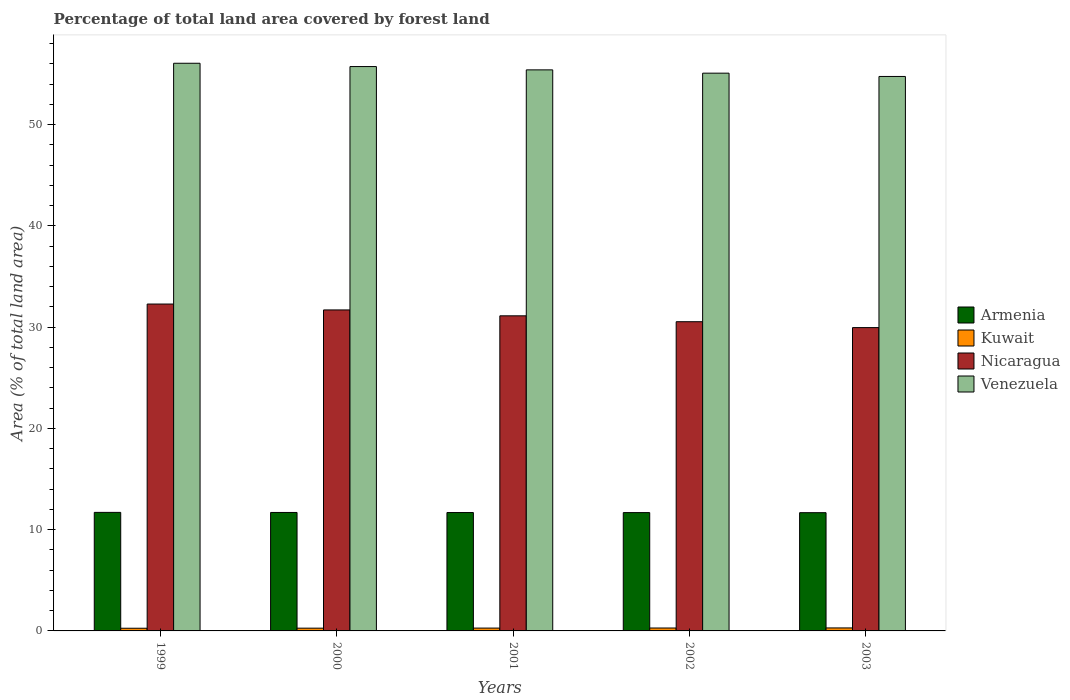How many different coloured bars are there?
Offer a terse response. 4. Are the number of bars per tick equal to the number of legend labels?
Your response must be concise. Yes. Are the number of bars on each tick of the X-axis equal?
Provide a succinct answer. Yes. How many bars are there on the 1st tick from the left?
Provide a succinct answer. 4. What is the label of the 3rd group of bars from the left?
Offer a very short reply. 2001. In how many cases, is the number of bars for a given year not equal to the number of legend labels?
Provide a short and direct response. 0. What is the percentage of forest land in Venezuela in 1999?
Offer a terse response. 56.05. Across all years, what is the maximum percentage of forest land in Kuwait?
Your response must be concise. 0.3. Across all years, what is the minimum percentage of forest land in Kuwait?
Provide a succinct answer. 0.26. What is the total percentage of forest land in Venezuela in the graph?
Provide a succinct answer. 276.99. What is the difference between the percentage of forest land in Armenia in 1999 and that in 2002?
Offer a very short reply. 0.02. What is the difference between the percentage of forest land in Nicaragua in 2000 and the percentage of forest land in Kuwait in 1999?
Keep it short and to the point. 31.43. What is the average percentage of forest land in Nicaragua per year?
Your response must be concise. 31.11. In the year 1999, what is the difference between the percentage of forest land in Venezuela and percentage of forest land in Armenia?
Offer a terse response. 44.35. In how many years, is the percentage of forest land in Venezuela greater than 14 %?
Make the answer very short. 5. What is the ratio of the percentage of forest land in Venezuela in 1999 to that in 2002?
Ensure brevity in your answer.  1.02. What is the difference between the highest and the second highest percentage of forest land in Kuwait?
Your answer should be compact. 0.01. What is the difference between the highest and the lowest percentage of forest land in Armenia?
Give a very brief answer. 0.03. Is the sum of the percentage of forest land in Kuwait in 1999 and 2001 greater than the maximum percentage of forest land in Armenia across all years?
Give a very brief answer. No. Is it the case that in every year, the sum of the percentage of forest land in Nicaragua and percentage of forest land in Kuwait is greater than the sum of percentage of forest land in Armenia and percentage of forest land in Venezuela?
Give a very brief answer. Yes. What does the 1st bar from the left in 1999 represents?
Provide a succinct answer. Armenia. What does the 4th bar from the right in 2002 represents?
Give a very brief answer. Armenia. How many bars are there?
Your response must be concise. 20. Are all the bars in the graph horizontal?
Provide a short and direct response. No. How many years are there in the graph?
Provide a short and direct response. 5. Are the values on the major ticks of Y-axis written in scientific E-notation?
Your response must be concise. No. Does the graph contain grids?
Your answer should be compact. No. How many legend labels are there?
Provide a succinct answer. 4. What is the title of the graph?
Your response must be concise. Percentage of total land area covered by forest land. Does "Mauritius" appear as one of the legend labels in the graph?
Provide a succinct answer. No. What is the label or title of the X-axis?
Your response must be concise. Years. What is the label or title of the Y-axis?
Make the answer very short. Area (% of total land area). What is the Area (% of total land area) of Armenia in 1999?
Offer a very short reply. 11.7. What is the Area (% of total land area) in Kuwait in 1999?
Provide a succinct answer. 0.26. What is the Area (% of total land area) in Nicaragua in 1999?
Make the answer very short. 32.28. What is the Area (% of total land area) in Venezuela in 1999?
Your response must be concise. 56.05. What is the Area (% of total land area) of Armenia in 2000?
Your answer should be very brief. 11.7. What is the Area (% of total land area) in Kuwait in 2000?
Keep it short and to the point. 0.27. What is the Area (% of total land area) of Nicaragua in 2000?
Offer a very short reply. 31.69. What is the Area (% of total land area) of Venezuela in 2000?
Give a very brief answer. 55.72. What is the Area (% of total land area) of Armenia in 2001?
Offer a very short reply. 11.69. What is the Area (% of total land area) of Kuwait in 2001?
Give a very brief answer. 0.28. What is the Area (% of total land area) in Nicaragua in 2001?
Your response must be concise. 31.11. What is the Area (% of total land area) of Venezuela in 2001?
Your response must be concise. 55.4. What is the Area (% of total land area) of Armenia in 2002?
Keep it short and to the point. 11.68. What is the Area (% of total land area) in Kuwait in 2002?
Ensure brevity in your answer.  0.29. What is the Area (% of total land area) of Nicaragua in 2002?
Make the answer very short. 30.53. What is the Area (% of total land area) of Venezuela in 2002?
Offer a very short reply. 55.07. What is the Area (% of total land area) of Armenia in 2003?
Ensure brevity in your answer.  11.68. What is the Area (% of total land area) of Kuwait in 2003?
Offer a terse response. 0.3. What is the Area (% of total land area) of Nicaragua in 2003?
Give a very brief answer. 29.95. What is the Area (% of total land area) of Venezuela in 2003?
Offer a very short reply. 54.75. Across all years, what is the maximum Area (% of total land area) in Armenia?
Your response must be concise. 11.7. Across all years, what is the maximum Area (% of total land area) in Kuwait?
Make the answer very short. 0.3. Across all years, what is the maximum Area (% of total land area) of Nicaragua?
Make the answer very short. 32.28. Across all years, what is the maximum Area (% of total land area) in Venezuela?
Your answer should be compact. 56.05. Across all years, what is the minimum Area (% of total land area) of Armenia?
Give a very brief answer. 11.68. Across all years, what is the minimum Area (% of total land area) of Kuwait?
Your answer should be compact. 0.26. Across all years, what is the minimum Area (% of total land area) of Nicaragua?
Offer a very short reply. 29.95. Across all years, what is the minimum Area (% of total land area) of Venezuela?
Provide a short and direct response. 54.75. What is the total Area (% of total land area) in Armenia in the graph?
Your answer should be very brief. 58.45. What is the total Area (% of total land area) in Kuwait in the graph?
Make the answer very short. 1.4. What is the total Area (% of total land area) of Nicaragua in the graph?
Offer a terse response. 155.56. What is the total Area (% of total land area) in Venezuela in the graph?
Make the answer very short. 276.99. What is the difference between the Area (% of total land area) of Armenia in 1999 and that in 2000?
Keep it short and to the point. 0.01. What is the difference between the Area (% of total land area) of Kuwait in 1999 and that in 2000?
Ensure brevity in your answer.  -0.01. What is the difference between the Area (% of total land area) of Nicaragua in 1999 and that in 2000?
Provide a succinct answer. 0.58. What is the difference between the Area (% of total land area) in Venezuela in 1999 and that in 2000?
Offer a terse response. 0.33. What is the difference between the Area (% of total land area) in Armenia in 1999 and that in 2001?
Your answer should be compact. 0.01. What is the difference between the Area (% of total land area) in Kuwait in 1999 and that in 2001?
Your answer should be very brief. -0.02. What is the difference between the Area (% of total land area) in Nicaragua in 1999 and that in 2001?
Your answer should be compact. 1.16. What is the difference between the Area (% of total land area) of Venezuela in 1999 and that in 2001?
Give a very brief answer. 0.65. What is the difference between the Area (% of total land area) in Armenia in 1999 and that in 2002?
Offer a very short reply. 0.02. What is the difference between the Area (% of total land area) of Kuwait in 1999 and that in 2002?
Give a very brief answer. -0.02. What is the difference between the Area (% of total land area) in Nicaragua in 1999 and that in 2002?
Give a very brief answer. 1.75. What is the difference between the Area (% of total land area) of Venezuela in 1999 and that in 2002?
Offer a terse response. 0.98. What is the difference between the Area (% of total land area) of Armenia in 1999 and that in 2003?
Your answer should be very brief. 0.03. What is the difference between the Area (% of total land area) of Kuwait in 1999 and that in 2003?
Provide a succinct answer. -0.03. What is the difference between the Area (% of total land area) of Nicaragua in 1999 and that in 2003?
Offer a very short reply. 2.33. What is the difference between the Area (% of total land area) in Venezuela in 1999 and that in 2003?
Make the answer very short. 1.3. What is the difference between the Area (% of total land area) of Armenia in 2000 and that in 2001?
Provide a succinct answer. 0.01. What is the difference between the Area (% of total land area) in Kuwait in 2000 and that in 2001?
Ensure brevity in your answer.  -0.01. What is the difference between the Area (% of total land area) in Nicaragua in 2000 and that in 2001?
Give a very brief answer. 0.58. What is the difference between the Area (% of total land area) of Venezuela in 2000 and that in 2001?
Your answer should be very brief. 0.33. What is the difference between the Area (% of total land area) of Armenia in 2000 and that in 2002?
Your answer should be very brief. 0.01. What is the difference between the Area (% of total land area) of Kuwait in 2000 and that in 2002?
Provide a succinct answer. -0.02. What is the difference between the Area (% of total land area) of Nicaragua in 2000 and that in 2002?
Provide a succinct answer. 1.16. What is the difference between the Area (% of total land area) in Venezuela in 2000 and that in 2002?
Keep it short and to the point. 0.65. What is the difference between the Area (% of total land area) in Armenia in 2000 and that in 2003?
Make the answer very short. 0.02. What is the difference between the Area (% of total land area) in Kuwait in 2000 and that in 2003?
Give a very brief answer. -0.02. What is the difference between the Area (% of total land area) in Nicaragua in 2000 and that in 2003?
Provide a short and direct response. 1.75. What is the difference between the Area (% of total land area) in Venezuela in 2000 and that in 2003?
Your answer should be very brief. 0.98. What is the difference between the Area (% of total land area) in Armenia in 2001 and that in 2002?
Offer a terse response. 0.01. What is the difference between the Area (% of total land area) in Kuwait in 2001 and that in 2002?
Provide a short and direct response. -0.01. What is the difference between the Area (% of total land area) of Nicaragua in 2001 and that in 2002?
Your answer should be compact. 0.58. What is the difference between the Area (% of total land area) in Venezuela in 2001 and that in 2002?
Provide a short and direct response. 0.33. What is the difference between the Area (% of total land area) in Armenia in 2001 and that in 2003?
Provide a short and direct response. 0.01. What is the difference between the Area (% of total land area) in Kuwait in 2001 and that in 2003?
Ensure brevity in your answer.  -0.02. What is the difference between the Area (% of total land area) in Nicaragua in 2001 and that in 2003?
Your answer should be compact. 1.16. What is the difference between the Area (% of total land area) in Venezuela in 2001 and that in 2003?
Make the answer very short. 0.65. What is the difference between the Area (% of total land area) in Armenia in 2002 and that in 2003?
Provide a short and direct response. 0.01. What is the difference between the Area (% of total land area) in Kuwait in 2002 and that in 2003?
Provide a succinct answer. -0.01. What is the difference between the Area (% of total land area) in Nicaragua in 2002 and that in 2003?
Keep it short and to the point. 0.58. What is the difference between the Area (% of total land area) in Venezuela in 2002 and that in 2003?
Keep it short and to the point. 0.33. What is the difference between the Area (% of total land area) in Armenia in 1999 and the Area (% of total land area) in Kuwait in 2000?
Ensure brevity in your answer.  11.43. What is the difference between the Area (% of total land area) of Armenia in 1999 and the Area (% of total land area) of Nicaragua in 2000?
Your response must be concise. -19.99. What is the difference between the Area (% of total land area) of Armenia in 1999 and the Area (% of total land area) of Venezuela in 2000?
Your answer should be compact. -44.02. What is the difference between the Area (% of total land area) in Kuwait in 1999 and the Area (% of total land area) in Nicaragua in 2000?
Your answer should be very brief. -31.43. What is the difference between the Area (% of total land area) in Kuwait in 1999 and the Area (% of total land area) in Venezuela in 2000?
Offer a terse response. -55.46. What is the difference between the Area (% of total land area) of Nicaragua in 1999 and the Area (% of total land area) of Venezuela in 2000?
Offer a very short reply. -23.45. What is the difference between the Area (% of total land area) in Armenia in 1999 and the Area (% of total land area) in Kuwait in 2001?
Give a very brief answer. 11.42. What is the difference between the Area (% of total land area) of Armenia in 1999 and the Area (% of total land area) of Nicaragua in 2001?
Your answer should be very brief. -19.41. What is the difference between the Area (% of total land area) in Armenia in 1999 and the Area (% of total land area) in Venezuela in 2001?
Ensure brevity in your answer.  -43.69. What is the difference between the Area (% of total land area) in Kuwait in 1999 and the Area (% of total land area) in Nicaragua in 2001?
Provide a short and direct response. -30.85. What is the difference between the Area (% of total land area) of Kuwait in 1999 and the Area (% of total land area) of Venezuela in 2001?
Your answer should be very brief. -55.13. What is the difference between the Area (% of total land area) of Nicaragua in 1999 and the Area (% of total land area) of Venezuela in 2001?
Offer a very short reply. -23.12. What is the difference between the Area (% of total land area) of Armenia in 1999 and the Area (% of total land area) of Kuwait in 2002?
Your response must be concise. 11.42. What is the difference between the Area (% of total land area) in Armenia in 1999 and the Area (% of total land area) in Nicaragua in 2002?
Provide a succinct answer. -18.83. What is the difference between the Area (% of total land area) in Armenia in 1999 and the Area (% of total land area) in Venezuela in 2002?
Provide a succinct answer. -43.37. What is the difference between the Area (% of total land area) of Kuwait in 1999 and the Area (% of total land area) of Nicaragua in 2002?
Provide a succinct answer. -30.27. What is the difference between the Area (% of total land area) of Kuwait in 1999 and the Area (% of total land area) of Venezuela in 2002?
Make the answer very short. -54.81. What is the difference between the Area (% of total land area) in Nicaragua in 1999 and the Area (% of total land area) in Venezuela in 2002?
Your answer should be very brief. -22.8. What is the difference between the Area (% of total land area) in Armenia in 1999 and the Area (% of total land area) in Kuwait in 2003?
Provide a short and direct response. 11.41. What is the difference between the Area (% of total land area) in Armenia in 1999 and the Area (% of total land area) in Nicaragua in 2003?
Ensure brevity in your answer.  -18.24. What is the difference between the Area (% of total land area) of Armenia in 1999 and the Area (% of total land area) of Venezuela in 2003?
Your response must be concise. -43.04. What is the difference between the Area (% of total land area) of Kuwait in 1999 and the Area (% of total land area) of Nicaragua in 2003?
Your response must be concise. -29.68. What is the difference between the Area (% of total land area) of Kuwait in 1999 and the Area (% of total land area) of Venezuela in 2003?
Make the answer very short. -54.48. What is the difference between the Area (% of total land area) in Nicaragua in 1999 and the Area (% of total land area) in Venezuela in 2003?
Your response must be concise. -22.47. What is the difference between the Area (% of total land area) in Armenia in 2000 and the Area (% of total land area) in Kuwait in 2001?
Provide a succinct answer. 11.42. What is the difference between the Area (% of total land area) of Armenia in 2000 and the Area (% of total land area) of Nicaragua in 2001?
Offer a terse response. -19.42. What is the difference between the Area (% of total land area) in Armenia in 2000 and the Area (% of total land area) in Venezuela in 2001?
Keep it short and to the point. -43.7. What is the difference between the Area (% of total land area) of Kuwait in 2000 and the Area (% of total land area) of Nicaragua in 2001?
Your answer should be compact. -30.84. What is the difference between the Area (% of total land area) of Kuwait in 2000 and the Area (% of total land area) of Venezuela in 2001?
Keep it short and to the point. -55.13. What is the difference between the Area (% of total land area) in Nicaragua in 2000 and the Area (% of total land area) in Venezuela in 2001?
Make the answer very short. -23.7. What is the difference between the Area (% of total land area) in Armenia in 2000 and the Area (% of total land area) in Kuwait in 2002?
Your response must be concise. 11.41. What is the difference between the Area (% of total land area) in Armenia in 2000 and the Area (% of total land area) in Nicaragua in 2002?
Provide a succinct answer. -18.83. What is the difference between the Area (% of total land area) of Armenia in 2000 and the Area (% of total land area) of Venezuela in 2002?
Keep it short and to the point. -43.38. What is the difference between the Area (% of total land area) of Kuwait in 2000 and the Area (% of total land area) of Nicaragua in 2002?
Offer a terse response. -30.26. What is the difference between the Area (% of total land area) in Kuwait in 2000 and the Area (% of total land area) in Venezuela in 2002?
Ensure brevity in your answer.  -54.8. What is the difference between the Area (% of total land area) of Nicaragua in 2000 and the Area (% of total land area) of Venezuela in 2002?
Offer a very short reply. -23.38. What is the difference between the Area (% of total land area) of Armenia in 2000 and the Area (% of total land area) of Kuwait in 2003?
Your response must be concise. 11.4. What is the difference between the Area (% of total land area) in Armenia in 2000 and the Area (% of total land area) in Nicaragua in 2003?
Offer a terse response. -18.25. What is the difference between the Area (% of total land area) in Armenia in 2000 and the Area (% of total land area) in Venezuela in 2003?
Ensure brevity in your answer.  -43.05. What is the difference between the Area (% of total land area) of Kuwait in 2000 and the Area (% of total land area) of Nicaragua in 2003?
Offer a terse response. -29.68. What is the difference between the Area (% of total land area) in Kuwait in 2000 and the Area (% of total land area) in Venezuela in 2003?
Your answer should be very brief. -54.47. What is the difference between the Area (% of total land area) of Nicaragua in 2000 and the Area (% of total land area) of Venezuela in 2003?
Offer a very short reply. -23.05. What is the difference between the Area (% of total land area) in Armenia in 2001 and the Area (% of total land area) in Kuwait in 2002?
Your response must be concise. 11.4. What is the difference between the Area (% of total land area) in Armenia in 2001 and the Area (% of total land area) in Nicaragua in 2002?
Keep it short and to the point. -18.84. What is the difference between the Area (% of total land area) of Armenia in 2001 and the Area (% of total land area) of Venezuela in 2002?
Your answer should be very brief. -43.38. What is the difference between the Area (% of total land area) of Kuwait in 2001 and the Area (% of total land area) of Nicaragua in 2002?
Ensure brevity in your answer.  -30.25. What is the difference between the Area (% of total land area) of Kuwait in 2001 and the Area (% of total land area) of Venezuela in 2002?
Keep it short and to the point. -54.79. What is the difference between the Area (% of total land area) in Nicaragua in 2001 and the Area (% of total land area) in Venezuela in 2002?
Offer a very short reply. -23.96. What is the difference between the Area (% of total land area) of Armenia in 2001 and the Area (% of total land area) of Kuwait in 2003?
Offer a terse response. 11.39. What is the difference between the Area (% of total land area) in Armenia in 2001 and the Area (% of total land area) in Nicaragua in 2003?
Your answer should be very brief. -18.26. What is the difference between the Area (% of total land area) in Armenia in 2001 and the Area (% of total land area) in Venezuela in 2003?
Offer a terse response. -43.06. What is the difference between the Area (% of total land area) of Kuwait in 2001 and the Area (% of total land area) of Nicaragua in 2003?
Ensure brevity in your answer.  -29.67. What is the difference between the Area (% of total land area) of Kuwait in 2001 and the Area (% of total land area) of Venezuela in 2003?
Give a very brief answer. -54.47. What is the difference between the Area (% of total land area) in Nicaragua in 2001 and the Area (% of total land area) in Venezuela in 2003?
Provide a succinct answer. -23.63. What is the difference between the Area (% of total land area) of Armenia in 2002 and the Area (% of total land area) of Kuwait in 2003?
Your answer should be very brief. 11.39. What is the difference between the Area (% of total land area) of Armenia in 2002 and the Area (% of total land area) of Nicaragua in 2003?
Ensure brevity in your answer.  -18.27. What is the difference between the Area (% of total land area) of Armenia in 2002 and the Area (% of total land area) of Venezuela in 2003?
Provide a succinct answer. -43.06. What is the difference between the Area (% of total land area) in Kuwait in 2002 and the Area (% of total land area) in Nicaragua in 2003?
Your answer should be very brief. -29.66. What is the difference between the Area (% of total land area) in Kuwait in 2002 and the Area (% of total land area) in Venezuela in 2003?
Offer a very short reply. -54.46. What is the difference between the Area (% of total land area) in Nicaragua in 2002 and the Area (% of total land area) in Venezuela in 2003?
Make the answer very short. -24.22. What is the average Area (% of total land area) of Armenia per year?
Ensure brevity in your answer.  11.69. What is the average Area (% of total land area) in Kuwait per year?
Offer a terse response. 0.28. What is the average Area (% of total land area) of Nicaragua per year?
Your response must be concise. 31.11. What is the average Area (% of total land area) of Venezuela per year?
Provide a short and direct response. 55.4. In the year 1999, what is the difference between the Area (% of total land area) of Armenia and Area (% of total land area) of Kuwait?
Provide a succinct answer. 11.44. In the year 1999, what is the difference between the Area (% of total land area) in Armenia and Area (% of total land area) in Nicaragua?
Give a very brief answer. -20.57. In the year 1999, what is the difference between the Area (% of total land area) in Armenia and Area (% of total land area) in Venezuela?
Your response must be concise. -44.35. In the year 1999, what is the difference between the Area (% of total land area) in Kuwait and Area (% of total land area) in Nicaragua?
Your answer should be compact. -32.01. In the year 1999, what is the difference between the Area (% of total land area) of Kuwait and Area (% of total land area) of Venezuela?
Ensure brevity in your answer.  -55.79. In the year 1999, what is the difference between the Area (% of total land area) in Nicaragua and Area (% of total land area) in Venezuela?
Your response must be concise. -23.77. In the year 2000, what is the difference between the Area (% of total land area) of Armenia and Area (% of total land area) of Kuwait?
Keep it short and to the point. 11.42. In the year 2000, what is the difference between the Area (% of total land area) of Armenia and Area (% of total land area) of Nicaragua?
Provide a succinct answer. -20. In the year 2000, what is the difference between the Area (% of total land area) in Armenia and Area (% of total land area) in Venezuela?
Give a very brief answer. -44.03. In the year 2000, what is the difference between the Area (% of total land area) of Kuwait and Area (% of total land area) of Nicaragua?
Offer a very short reply. -31.42. In the year 2000, what is the difference between the Area (% of total land area) of Kuwait and Area (% of total land area) of Venezuela?
Give a very brief answer. -55.45. In the year 2000, what is the difference between the Area (% of total land area) in Nicaragua and Area (% of total land area) in Venezuela?
Your answer should be compact. -24.03. In the year 2001, what is the difference between the Area (% of total land area) in Armenia and Area (% of total land area) in Kuwait?
Give a very brief answer. 11.41. In the year 2001, what is the difference between the Area (% of total land area) in Armenia and Area (% of total land area) in Nicaragua?
Give a very brief answer. -19.42. In the year 2001, what is the difference between the Area (% of total land area) of Armenia and Area (% of total land area) of Venezuela?
Make the answer very short. -43.71. In the year 2001, what is the difference between the Area (% of total land area) of Kuwait and Area (% of total land area) of Nicaragua?
Your response must be concise. -30.83. In the year 2001, what is the difference between the Area (% of total land area) in Kuwait and Area (% of total land area) in Venezuela?
Keep it short and to the point. -55.12. In the year 2001, what is the difference between the Area (% of total land area) in Nicaragua and Area (% of total land area) in Venezuela?
Offer a terse response. -24.29. In the year 2002, what is the difference between the Area (% of total land area) of Armenia and Area (% of total land area) of Kuwait?
Your answer should be compact. 11.39. In the year 2002, what is the difference between the Area (% of total land area) in Armenia and Area (% of total land area) in Nicaragua?
Give a very brief answer. -18.85. In the year 2002, what is the difference between the Area (% of total land area) in Armenia and Area (% of total land area) in Venezuela?
Offer a terse response. -43.39. In the year 2002, what is the difference between the Area (% of total land area) of Kuwait and Area (% of total land area) of Nicaragua?
Provide a short and direct response. -30.24. In the year 2002, what is the difference between the Area (% of total land area) in Kuwait and Area (% of total land area) in Venezuela?
Your response must be concise. -54.78. In the year 2002, what is the difference between the Area (% of total land area) in Nicaragua and Area (% of total land area) in Venezuela?
Offer a very short reply. -24.54. In the year 2003, what is the difference between the Area (% of total land area) in Armenia and Area (% of total land area) in Kuwait?
Your response must be concise. 11.38. In the year 2003, what is the difference between the Area (% of total land area) in Armenia and Area (% of total land area) in Nicaragua?
Your answer should be very brief. -18.27. In the year 2003, what is the difference between the Area (% of total land area) in Armenia and Area (% of total land area) in Venezuela?
Keep it short and to the point. -43.07. In the year 2003, what is the difference between the Area (% of total land area) in Kuwait and Area (% of total land area) in Nicaragua?
Make the answer very short. -29.65. In the year 2003, what is the difference between the Area (% of total land area) in Kuwait and Area (% of total land area) in Venezuela?
Offer a terse response. -54.45. In the year 2003, what is the difference between the Area (% of total land area) of Nicaragua and Area (% of total land area) of Venezuela?
Provide a succinct answer. -24.8. What is the ratio of the Area (% of total land area) of Armenia in 1999 to that in 2000?
Your response must be concise. 1. What is the ratio of the Area (% of total land area) in Kuwait in 1999 to that in 2000?
Your answer should be compact. 0.97. What is the ratio of the Area (% of total land area) of Nicaragua in 1999 to that in 2000?
Give a very brief answer. 1.02. What is the ratio of the Area (% of total land area) in Armenia in 1999 to that in 2001?
Give a very brief answer. 1. What is the ratio of the Area (% of total land area) in Kuwait in 1999 to that in 2001?
Provide a succinct answer. 0.94. What is the ratio of the Area (% of total land area) in Nicaragua in 1999 to that in 2001?
Ensure brevity in your answer.  1.04. What is the ratio of the Area (% of total land area) of Venezuela in 1999 to that in 2001?
Keep it short and to the point. 1.01. What is the ratio of the Area (% of total land area) of Armenia in 1999 to that in 2002?
Your answer should be very brief. 1. What is the ratio of the Area (% of total land area) in Kuwait in 1999 to that in 2002?
Your answer should be compact. 0.92. What is the ratio of the Area (% of total land area) of Nicaragua in 1999 to that in 2002?
Provide a short and direct response. 1.06. What is the ratio of the Area (% of total land area) of Venezuela in 1999 to that in 2002?
Ensure brevity in your answer.  1.02. What is the ratio of the Area (% of total land area) in Kuwait in 1999 to that in 2003?
Give a very brief answer. 0.89. What is the ratio of the Area (% of total land area) in Nicaragua in 1999 to that in 2003?
Provide a short and direct response. 1.08. What is the ratio of the Area (% of total land area) of Venezuela in 1999 to that in 2003?
Give a very brief answer. 1.02. What is the ratio of the Area (% of total land area) of Kuwait in 2000 to that in 2001?
Make the answer very short. 0.97. What is the ratio of the Area (% of total land area) of Nicaragua in 2000 to that in 2001?
Offer a very short reply. 1.02. What is the ratio of the Area (% of total land area) of Venezuela in 2000 to that in 2001?
Give a very brief answer. 1.01. What is the ratio of the Area (% of total land area) in Armenia in 2000 to that in 2002?
Provide a succinct answer. 1. What is the ratio of the Area (% of total land area) of Kuwait in 2000 to that in 2002?
Make the answer very short. 0.95. What is the ratio of the Area (% of total land area) of Nicaragua in 2000 to that in 2002?
Keep it short and to the point. 1.04. What is the ratio of the Area (% of total land area) of Venezuela in 2000 to that in 2002?
Your answer should be compact. 1.01. What is the ratio of the Area (% of total land area) in Kuwait in 2000 to that in 2003?
Your answer should be compact. 0.92. What is the ratio of the Area (% of total land area) of Nicaragua in 2000 to that in 2003?
Give a very brief answer. 1.06. What is the ratio of the Area (% of total land area) of Venezuela in 2000 to that in 2003?
Offer a terse response. 1.02. What is the ratio of the Area (% of total land area) in Kuwait in 2001 to that in 2002?
Make the answer very short. 0.97. What is the ratio of the Area (% of total land area) in Nicaragua in 2001 to that in 2002?
Provide a succinct answer. 1.02. What is the ratio of the Area (% of total land area) of Venezuela in 2001 to that in 2002?
Your answer should be compact. 1.01. What is the ratio of the Area (% of total land area) in Armenia in 2001 to that in 2003?
Your answer should be very brief. 1. What is the ratio of the Area (% of total land area) of Kuwait in 2001 to that in 2003?
Your response must be concise. 0.95. What is the ratio of the Area (% of total land area) of Nicaragua in 2001 to that in 2003?
Offer a terse response. 1.04. What is the ratio of the Area (% of total land area) of Venezuela in 2001 to that in 2003?
Offer a terse response. 1.01. What is the ratio of the Area (% of total land area) of Kuwait in 2002 to that in 2003?
Make the answer very short. 0.97. What is the ratio of the Area (% of total land area) in Nicaragua in 2002 to that in 2003?
Provide a succinct answer. 1.02. What is the ratio of the Area (% of total land area) of Venezuela in 2002 to that in 2003?
Ensure brevity in your answer.  1.01. What is the difference between the highest and the second highest Area (% of total land area) in Armenia?
Your response must be concise. 0.01. What is the difference between the highest and the second highest Area (% of total land area) in Kuwait?
Ensure brevity in your answer.  0.01. What is the difference between the highest and the second highest Area (% of total land area) in Nicaragua?
Provide a short and direct response. 0.58. What is the difference between the highest and the second highest Area (% of total land area) of Venezuela?
Provide a succinct answer. 0.33. What is the difference between the highest and the lowest Area (% of total land area) of Armenia?
Your response must be concise. 0.03. What is the difference between the highest and the lowest Area (% of total land area) of Kuwait?
Your response must be concise. 0.03. What is the difference between the highest and the lowest Area (% of total land area) in Nicaragua?
Keep it short and to the point. 2.33. What is the difference between the highest and the lowest Area (% of total land area) of Venezuela?
Provide a succinct answer. 1.3. 